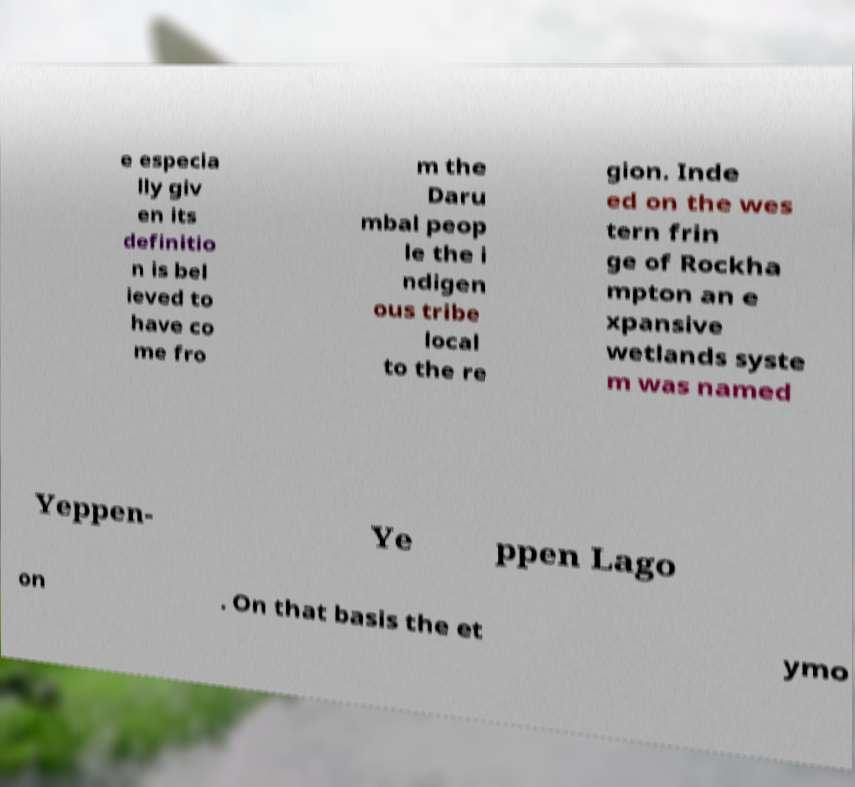Please identify and transcribe the text found in this image. e especia lly giv en its definitio n is bel ieved to have co me fro m the Daru mbal peop le the i ndigen ous tribe local to the re gion. Inde ed on the wes tern frin ge of Rockha mpton an e xpansive wetlands syste m was named Yeppen- Ye ppen Lago on . On that basis the et ymo 